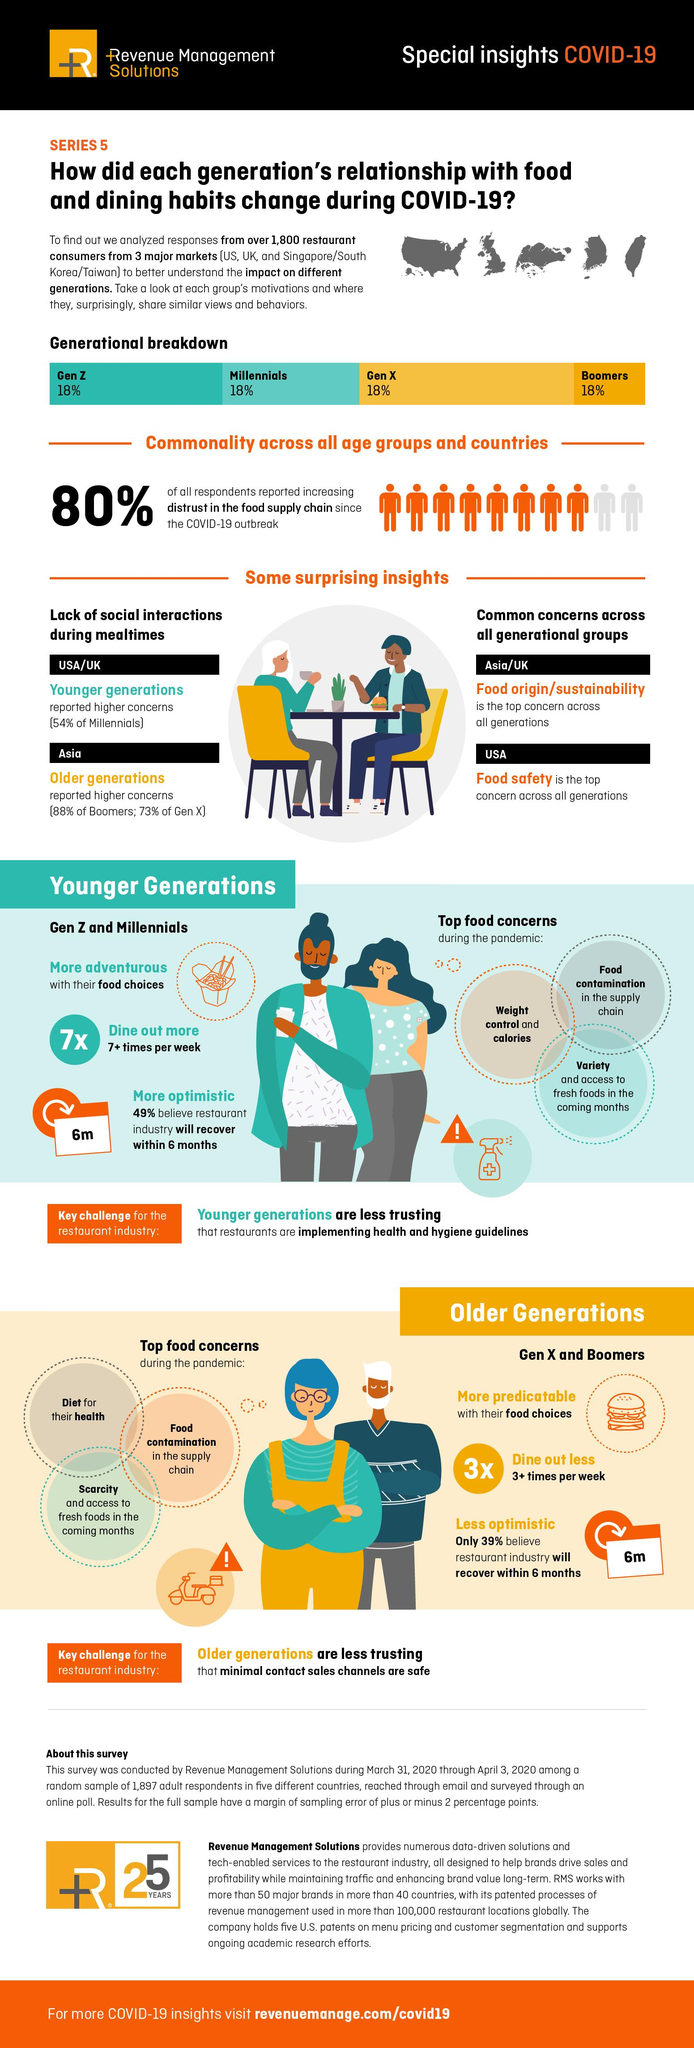Highlight a few significant elements in this photo. According to the source, Gen Z and Millennials are more likely to be adventurous in their food choices than other generations. It is commonly believed that younger generations are skeptical about the implementation of health and hygiene guidelines in restaurants. Across Asia and the UK, all generations share a common concern for food origin and sustainability. Older generations distrust minimal contact sales channels in restaurants because they believe they are safe. The main concern of all generations in the USA is food safety. 